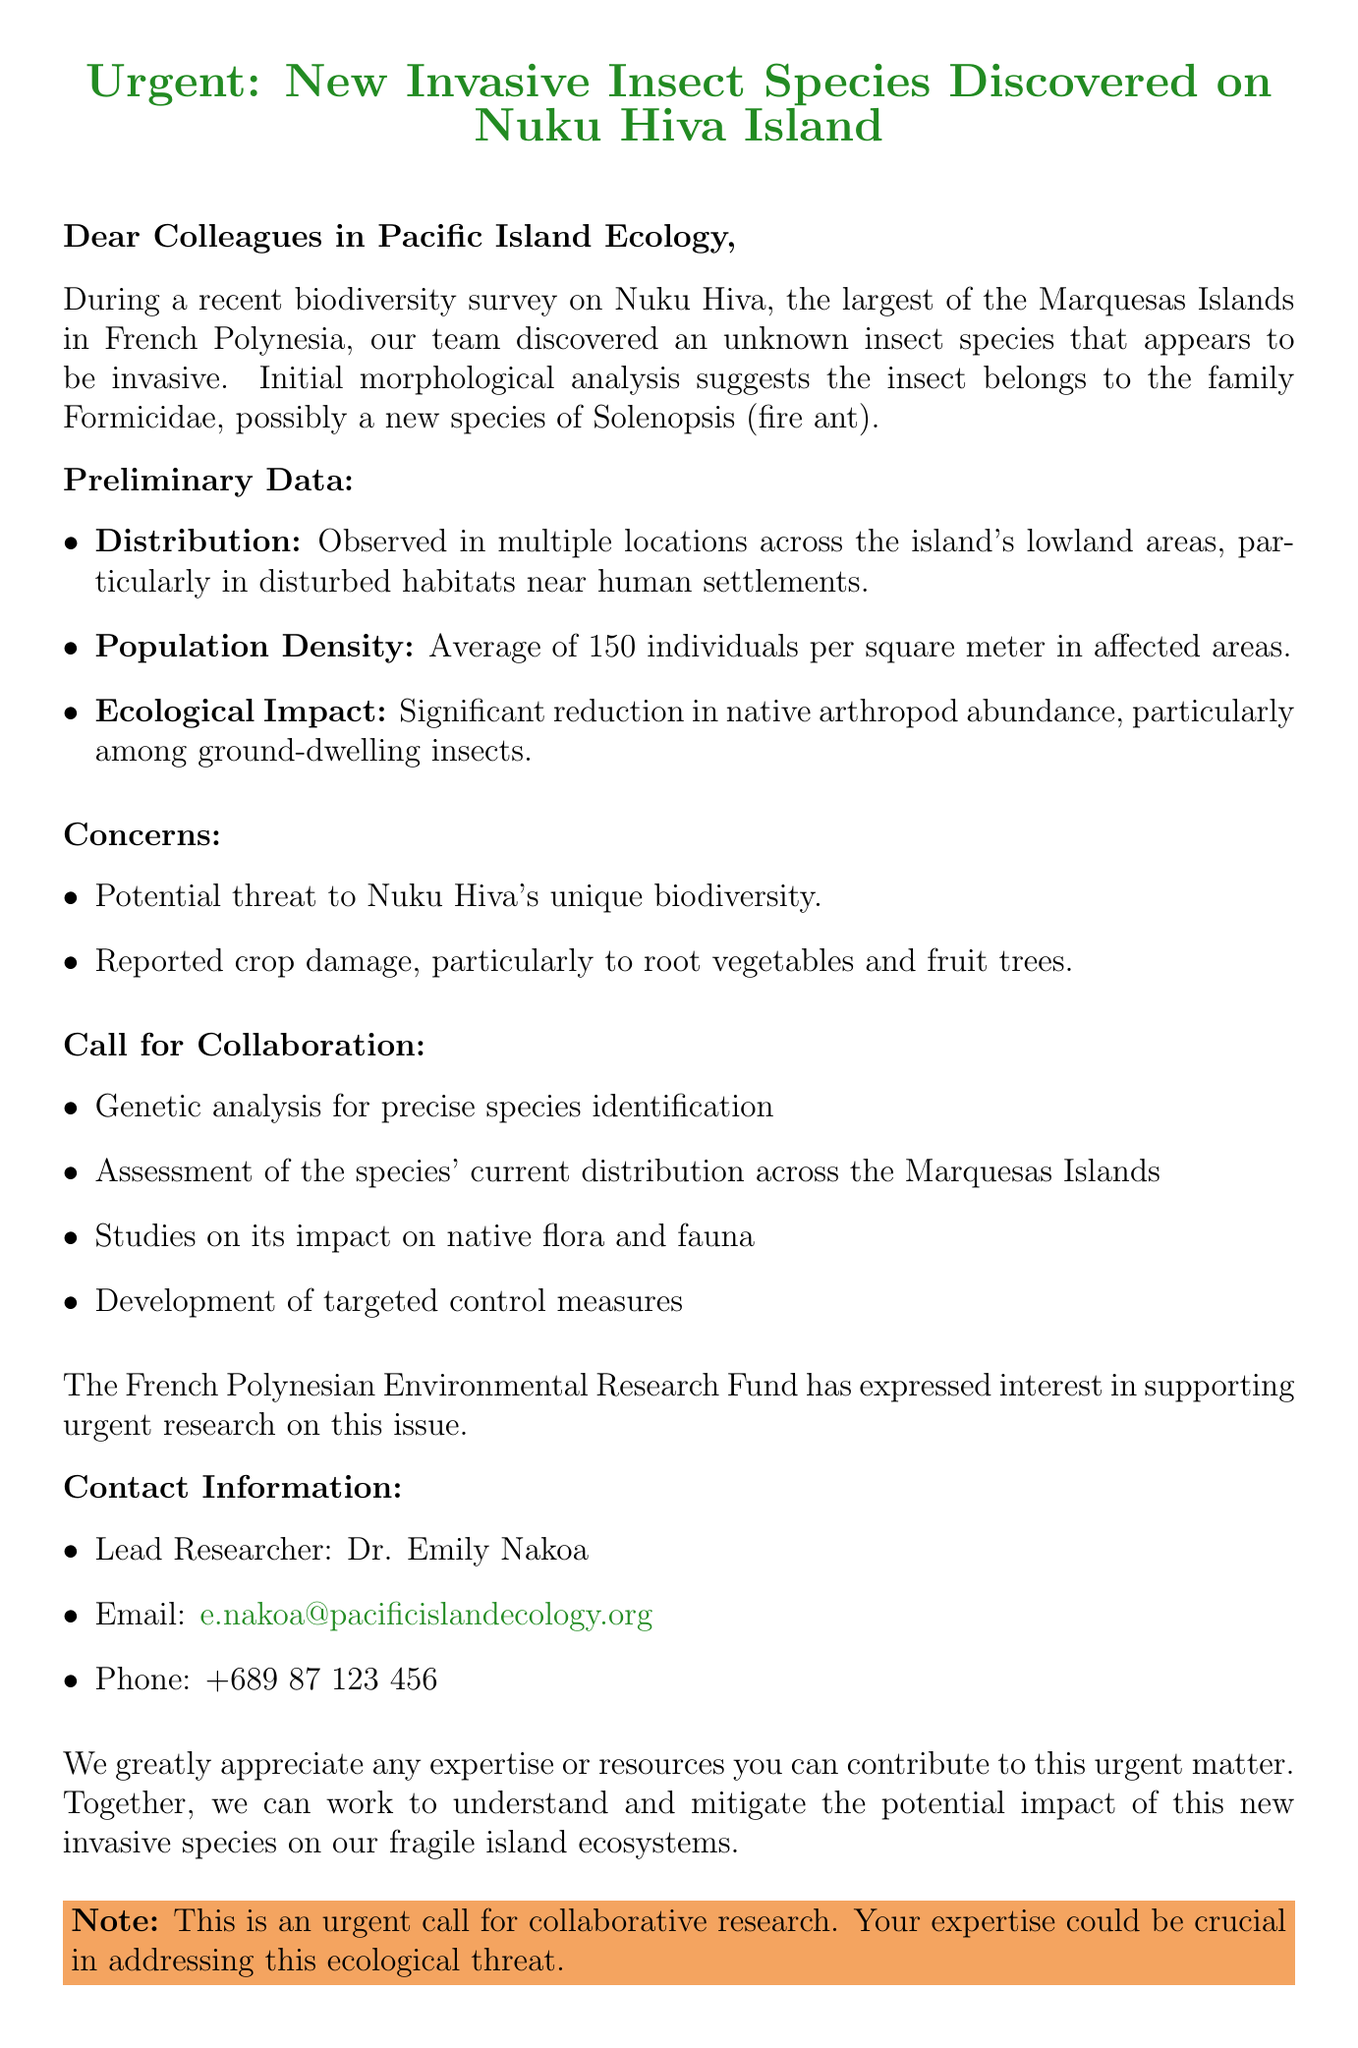What is the newly discovered invasive insect species? The document suggests that the insect belongs to the family Formicidae, possibly a new species of Solenopsis (fire ant).
Answer: Solenopsis What is the average population density of the species? The document states that preliminary surveys indicate a high population density, with an average of 150 individuals per square meter in affected areas.
Answer: 150 individuals per square meter Which island is the species discovered on? The email specifies that the discovery was made on Nuku Hiva, the largest of the Marquesas Islands in French Polynesia.
Answer: Nuku Hiva What are two concerns related to this invasive species? The document mentions two concerns: potential threat to Nuku Hiva's unique biodiversity and reported crop damage, particularly to root vegetables and fruit trees.
Answer: Unique biodiversity and crop damage Who is the lead researcher for this investigation? The document lists Dr. Emily Nakoa as the lead researcher responsible for gathering further data on the newly discovered species.
Answer: Dr. Emily Nakoa What is the funding opportunity mentioned in the email? The document states that the French Polynesian Environmental Research Fund has expressed interest in supporting urgent research on this issue.
Answer: French Polynesian Environmental Research Fund What type of species is this insect believed to be? The email describes the insect as potentially a new species of fire ant belonging to the family Formicidae.
Answer: Fire ant What kind of studies are being called for? The email outlines several research needs, including genetic analysis, assessment of current distribution, studies on native flora and fauna, and targeted control measures.
Answer: Genetic analysis, assessment, studies, control measures What has been observed in native arthropod abundance due to this species? The document indicates a significant reduction in native arthropod abundance in areas where this invasive species is present.
Answer: Significant reduction 